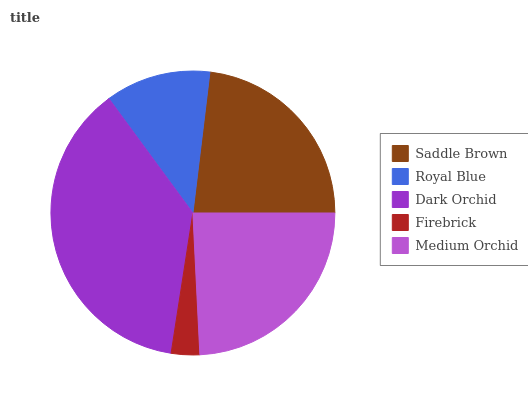Is Firebrick the minimum?
Answer yes or no. Yes. Is Dark Orchid the maximum?
Answer yes or no. Yes. Is Royal Blue the minimum?
Answer yes or no. No. Is Royal Blue the maximum?
Answer yes or no. No. Is Saddle Brown greater than Royal Blue?
Answer yes or no. Yes. Is Royal Blue less than Saddle Brown?
Answer yes or no. Yes. Is Royal Blue greater than Saddle Brown?
Answer yes or no. No. Is Saddle Brown less than Royal Blue?
Answer yes or no. No. Is Saddle Brown the high median?
Answer yes or no. Yes. Is Saddle Brown the low median?
Answer yes or no. Yes. Is Firebrick the high median?
Answer yes or no. No. Is Medium Orchid the low median?
Answer yes or no. No. 